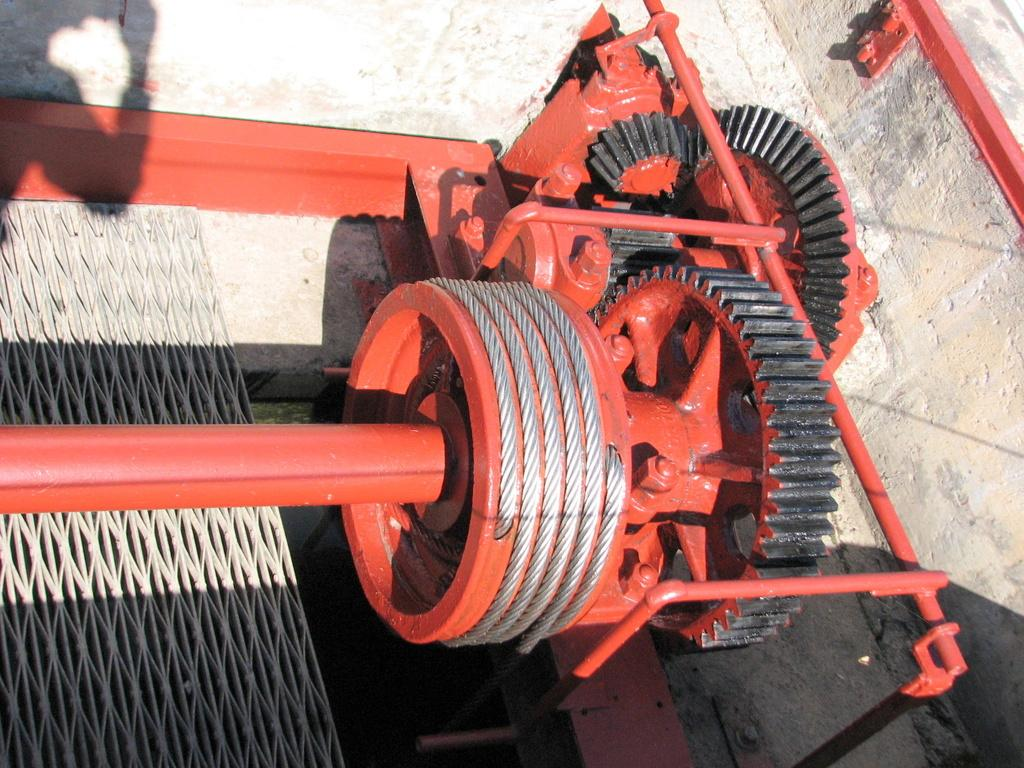What is the main object in the image? There is a machine in the image. What is on the ground near the machine? There is a mesh on the ground in the image. What can be seen in the background of the image? There is a wall in the background of the image. What type of instrument is being played by the person in the image? There is no person or instrument present in the image; it only features a machine, mesh, and wall. 